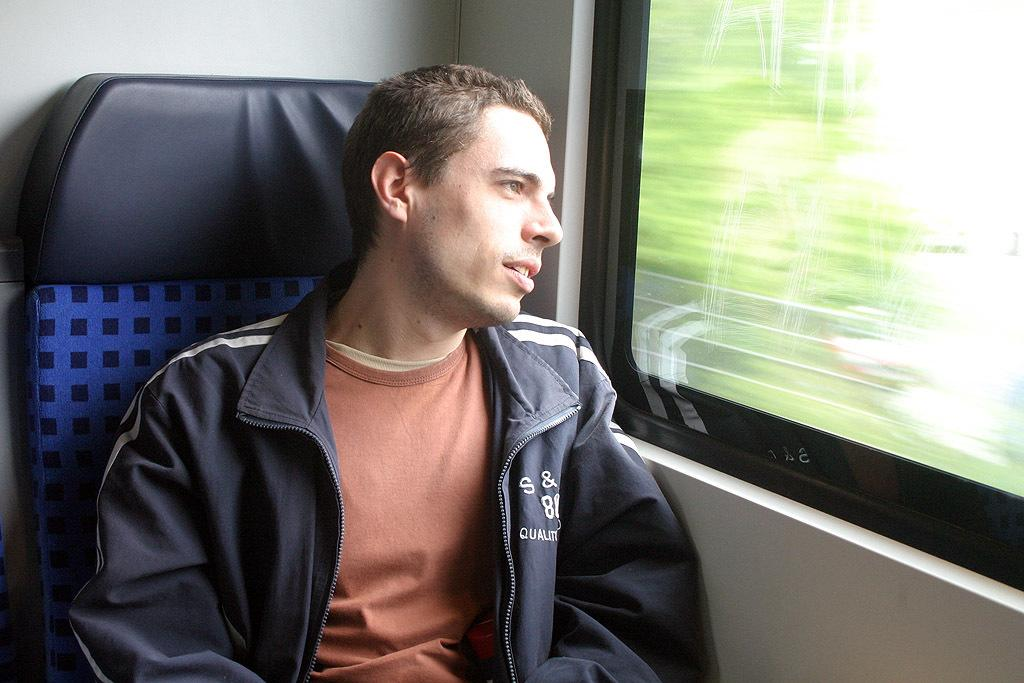What is the man in the image doing? The man is sitting on a seat in the image. What can be seen in the background of the image? There is a glass window in the image that provides a blurred view of the scene outside. How many tomatoes can be seen hanging from the ceiling in the image? There are no tomatoes present in the image. What is the position of the moon in the image? There is no moon visible in the image. 